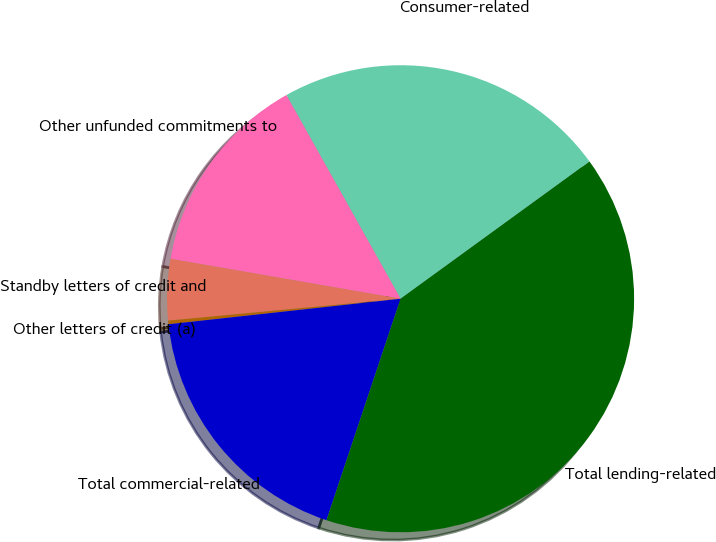Convert chart to OTSL. <chart><loc_0><loc_0><loc_500><loc_500><pie_chart><fcel>Consumer-related<fcel>Other unfunded commitments to<fcel>Standby letters of credit and<fcel>Other letters of credit (a)<fcel>Total commercial-related<fcel>Total lending-related<nl><fcel>23.13%<fcel>14.13%<fcel>4.23%<fcel>0.25%<fcel>18.12%<fcel>40.13%<nl></chart> 